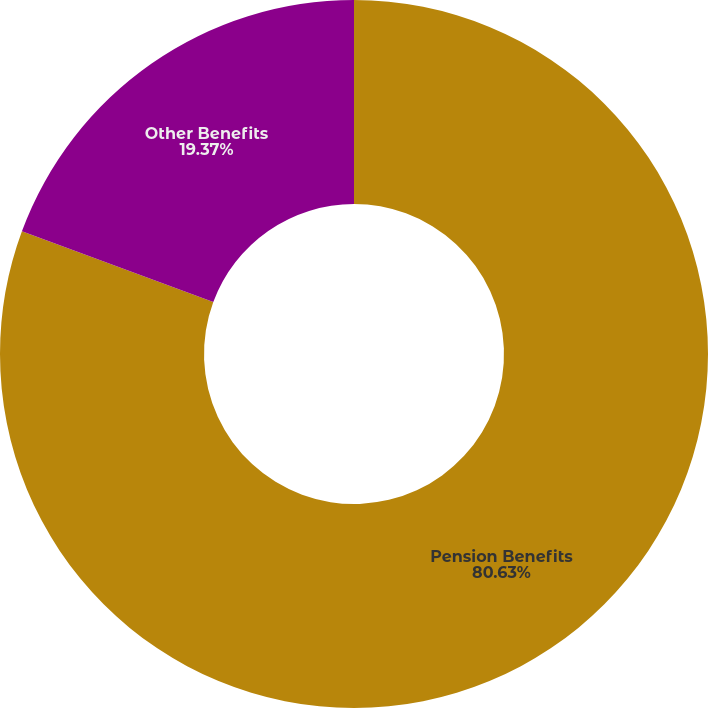<chart> <loc_0><loc_0><loc_500><loc_500><pie_chart><fcel>Pension Benefits<fcel>Other Benefits<nl><fcel>80.63%<fcel>19.37%<nl></chart> 